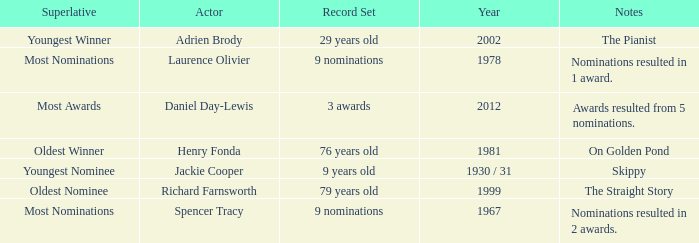What actor won in 1978? Laurence Olivier. 